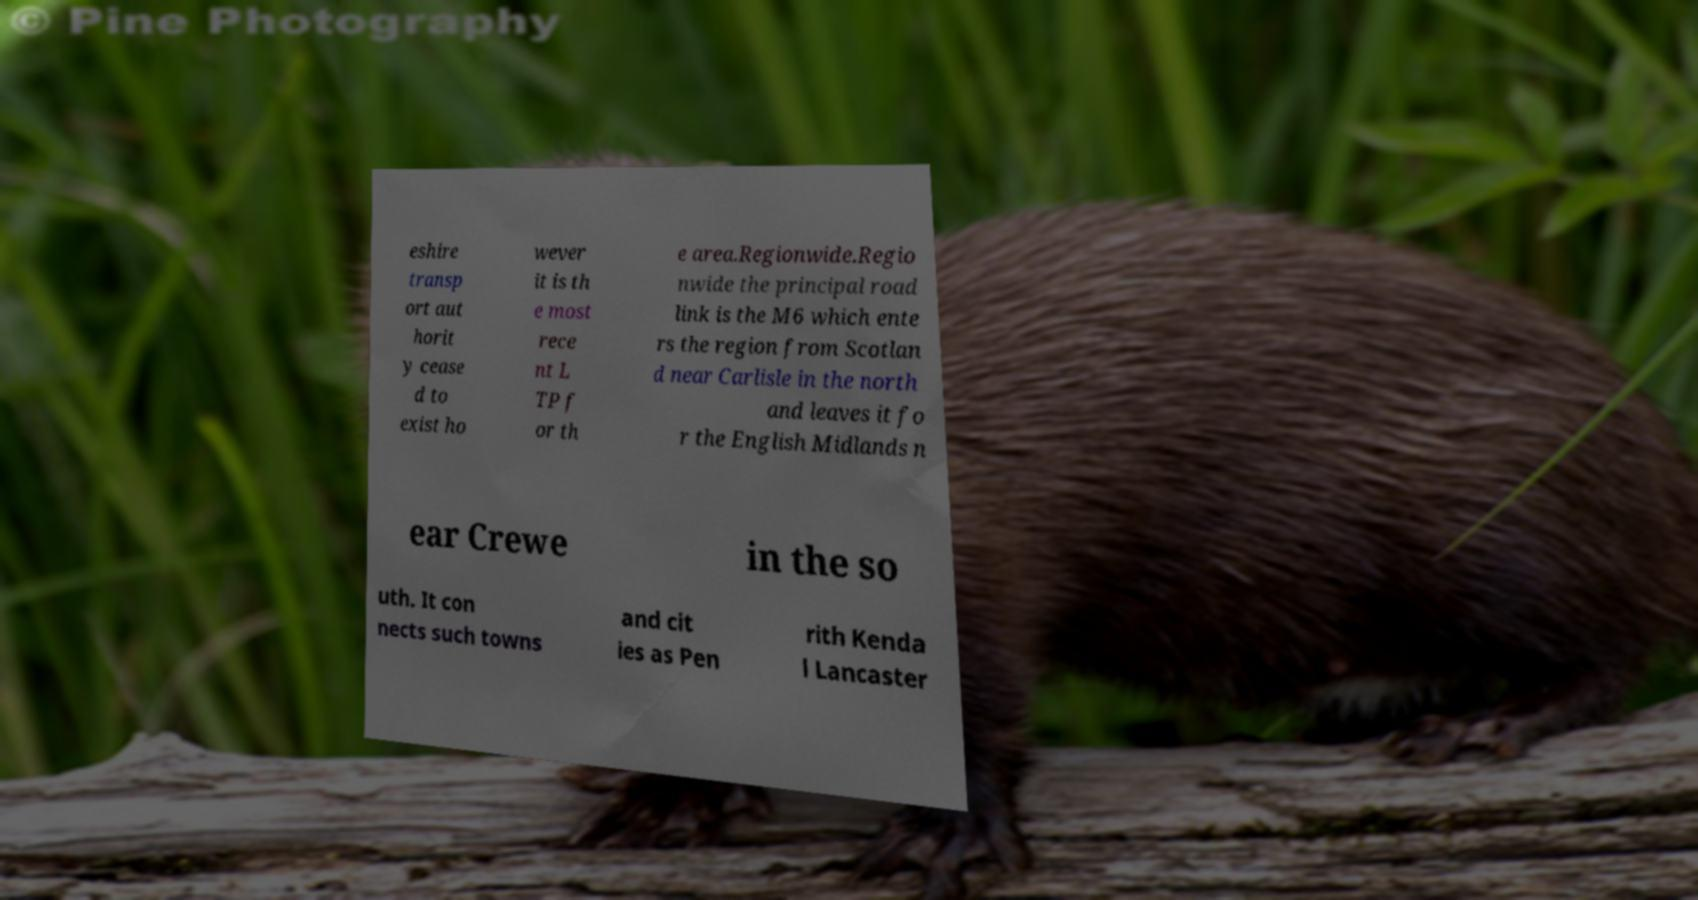There's text embedded in this image that I need extracted. Can you transcribe it verbatim? eshire transp ort aut horit y cease d to exist ho wever it is th e most rece nt L TP f or th e area.Regionwide.Regio nwide the principal road link is the M6 which ente rs the region from Scotlan d near Carlisle in the north and leaves it fo r the English Midlands n ear Crewe in the so uth. It con nects such towns and cit ies as Pen rith Kenda l Lancaster 